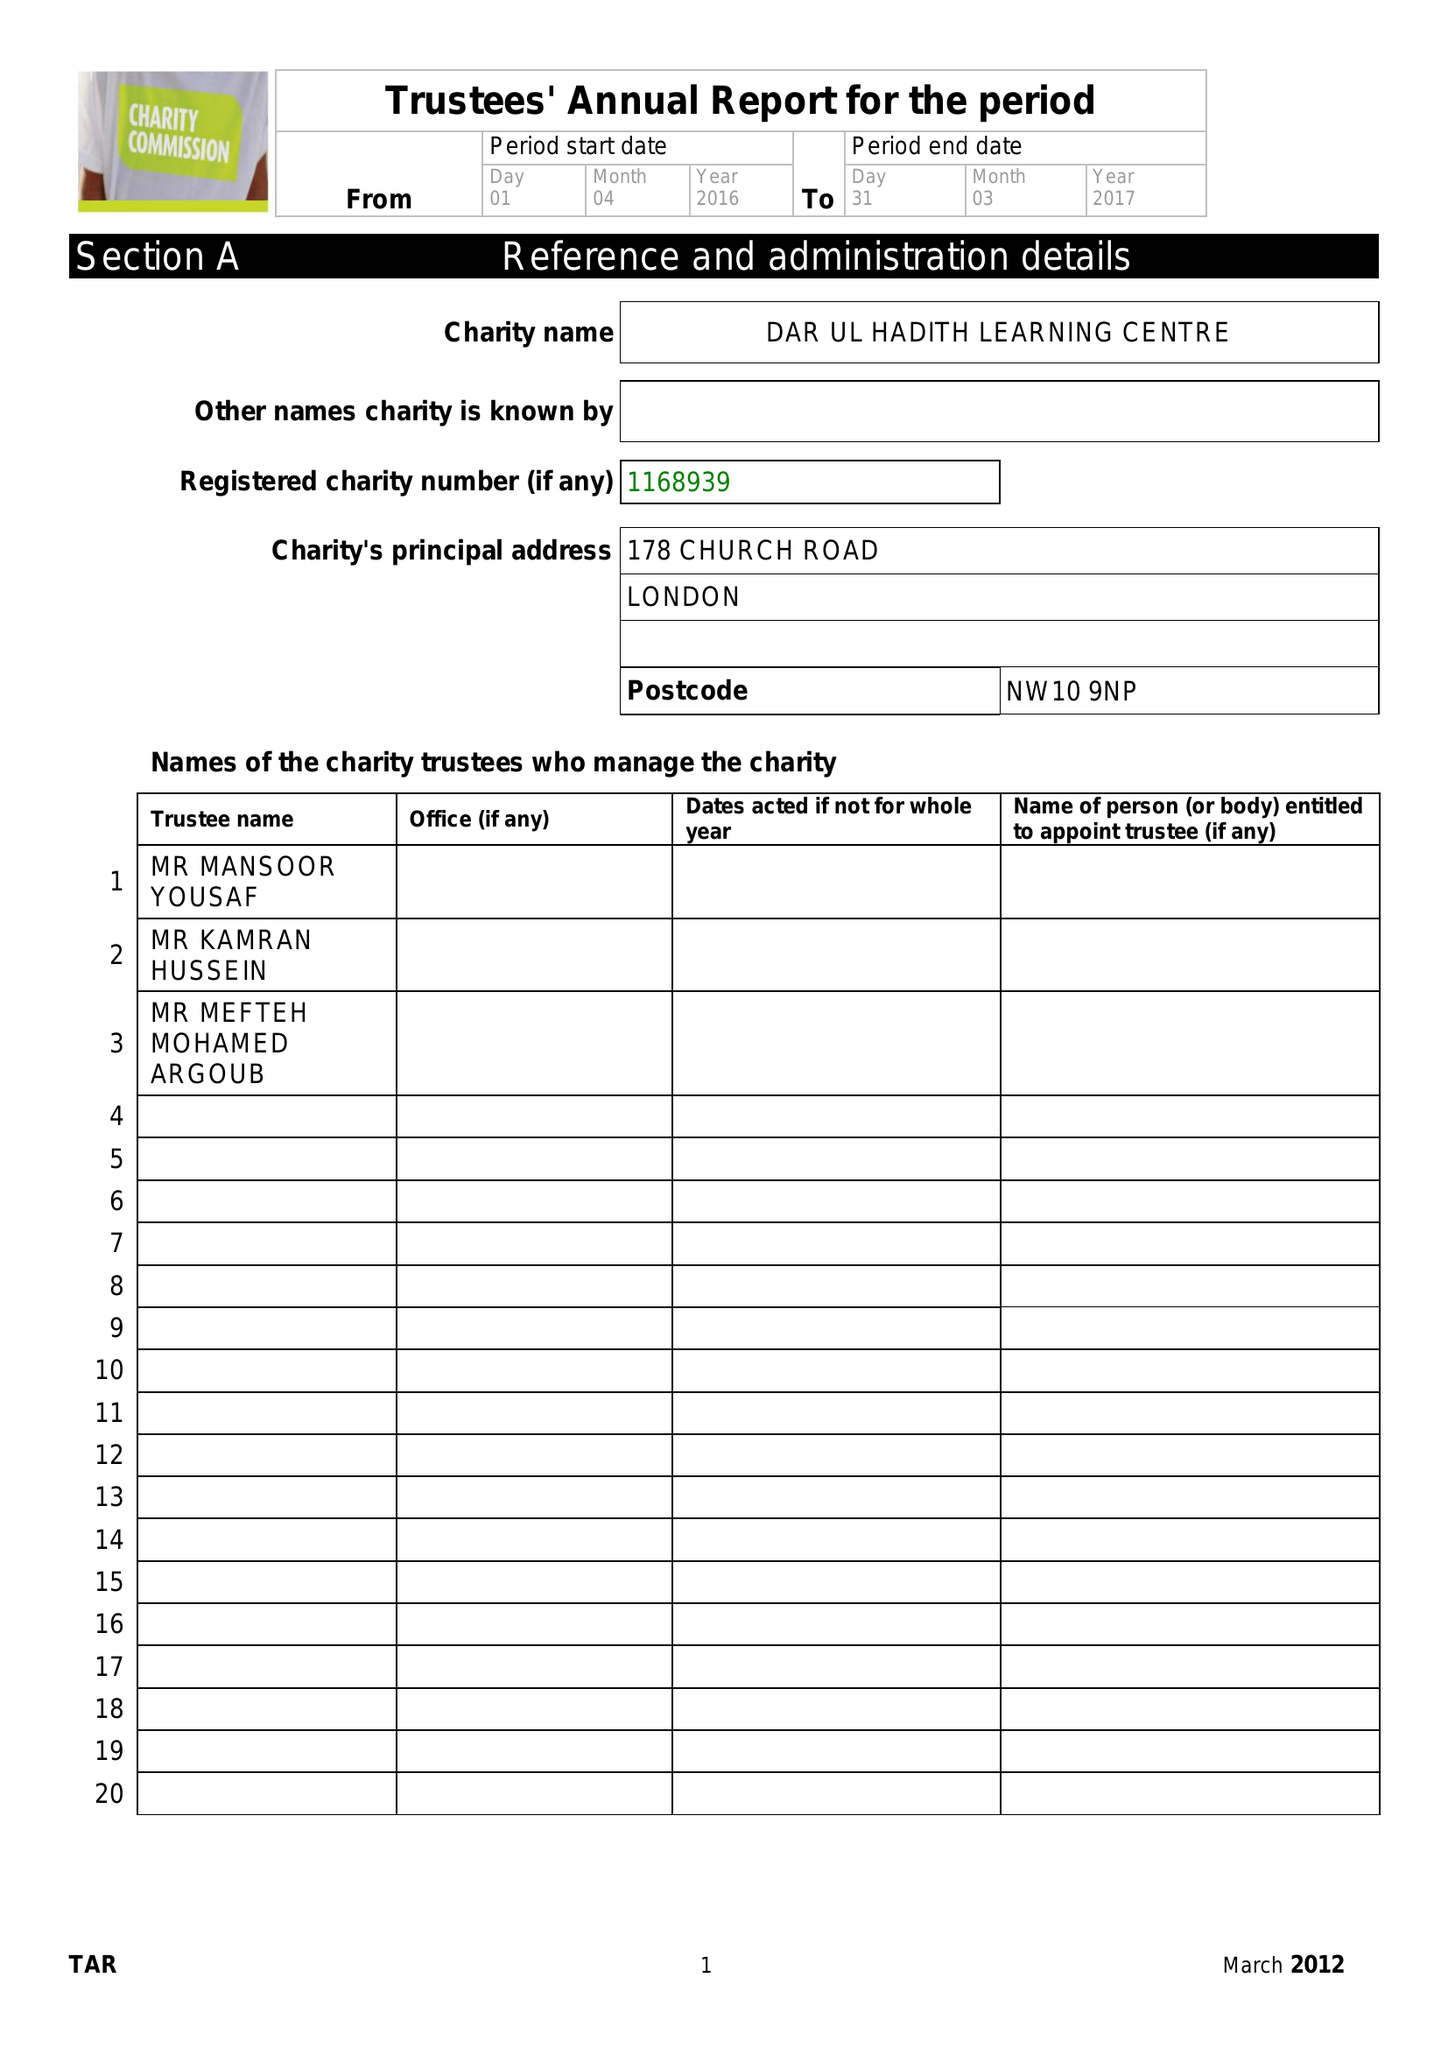What is the value for the income_annually_in_british_pounds?
Answer the question using a single word or phrase. 9625.00 